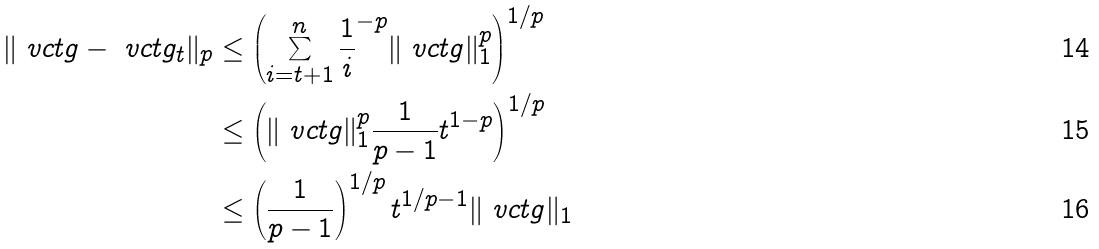Convert formula to latex. <formula><loc_0><loc_0><loc_500><loc_500>\| \ v c t { g } - \ v c t { g } _ { t } \| _ { p } & \leq \left ( \sum _ { i = t + 1 } ^ { n } \frac { 1 } i ^ { - p } \| \ v c t { g } \| _ { 1 } ^ { p } \right ) ^ { 1 / p } \\ & \leq \left ( \| \ v c t { g } \| _ { 1 } ^ { p } \frac { 1 } { p - 1 } t ^ { 1 - p } \right ) ^ { 1 / p } \\ & \leq \left ( \frac { 1 } { p - 1 } \right ) ^ { 1 / p } t ^ { 1 / p - 1 } \| \ v c t { g } \| _ { 1 }</formula> 